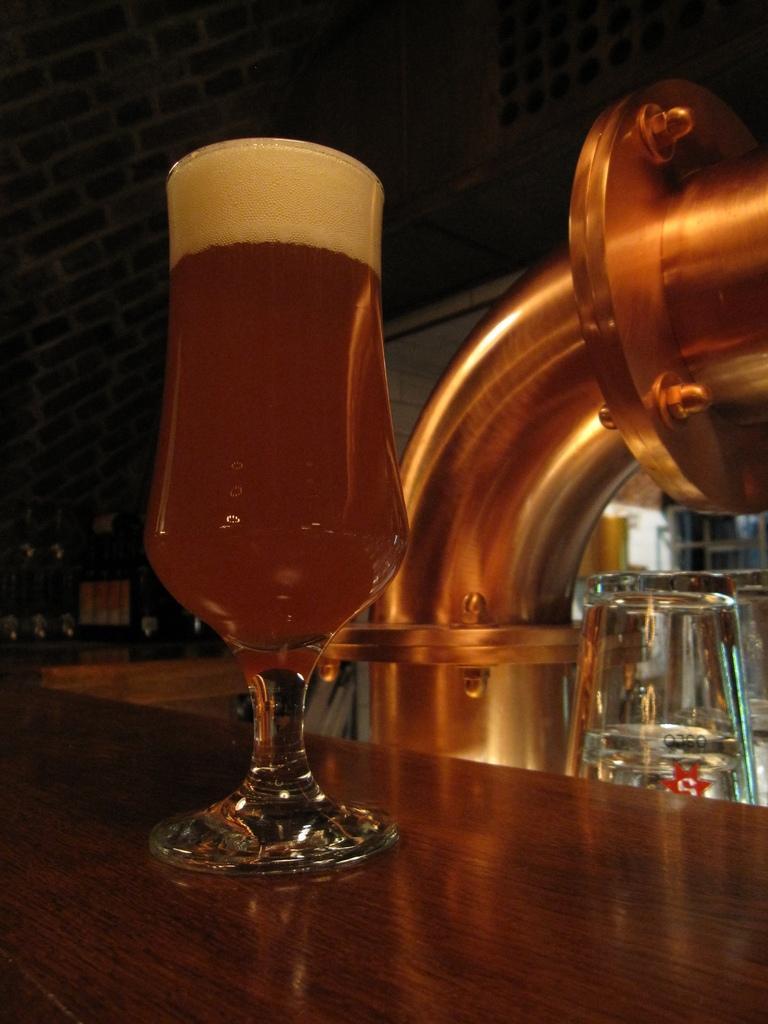Could you give a brief overview of what you see in this image? This picture shows a wine glass on the table. 